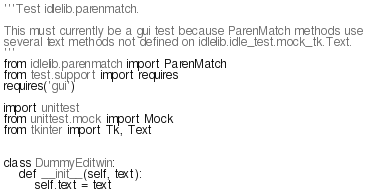<code> <loc_0><loc_0><loc_500><loc_500><_Python_>'''Test idlelib.parenmatch.

This must currently be a gui test because ParenMatch methods use
several text methods not defined on idlelib.idle_test.mock_tk.Text.
'''
from idlelib.parenmatch import ParenMatch
from test.support import requires
requires('gui')

import unittest
from unittest.mock import Mock
from tkinter import Tk, Text


class DummyEditwin:
    def __init__(self, text):
        self.text = text</code> 